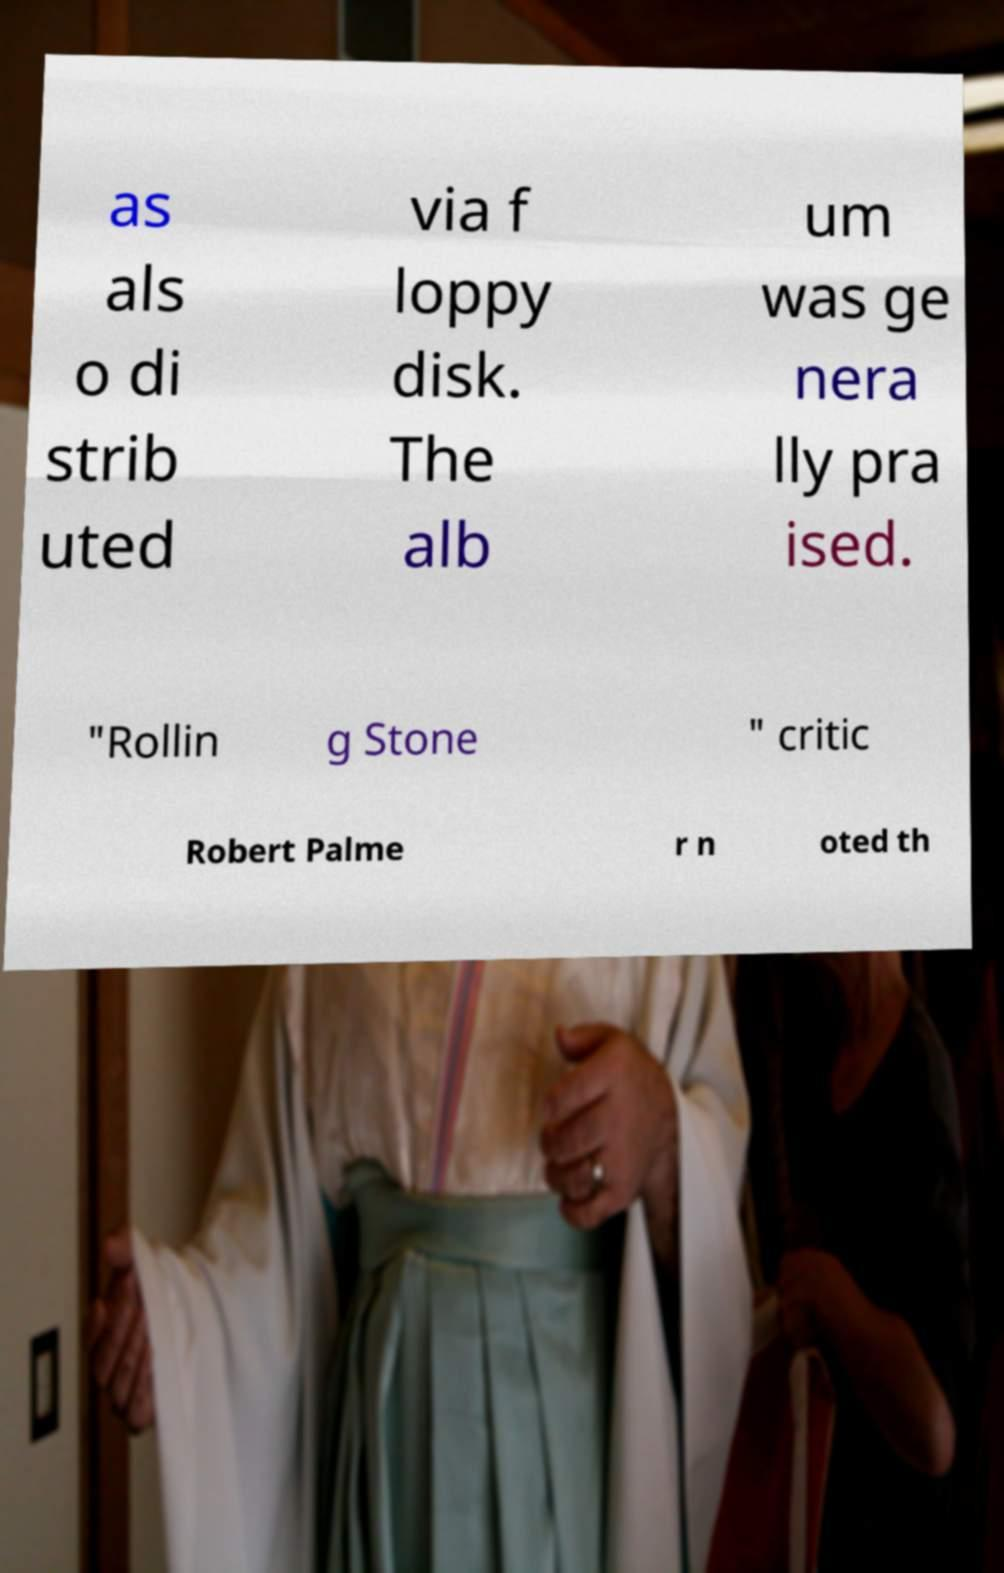Could you assist in decoding the text presented in this image and type it out clearly? as als o di strib uted via f loppy disk. The alb um was ge nera lly pra ised. "Rollin g Stone " critic Robert Palme r n oted th 